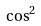Convert formula to latex. <formula><loc_0><loc_0><loc_500><loc_500>\cos ^ { 2 }</formula> 